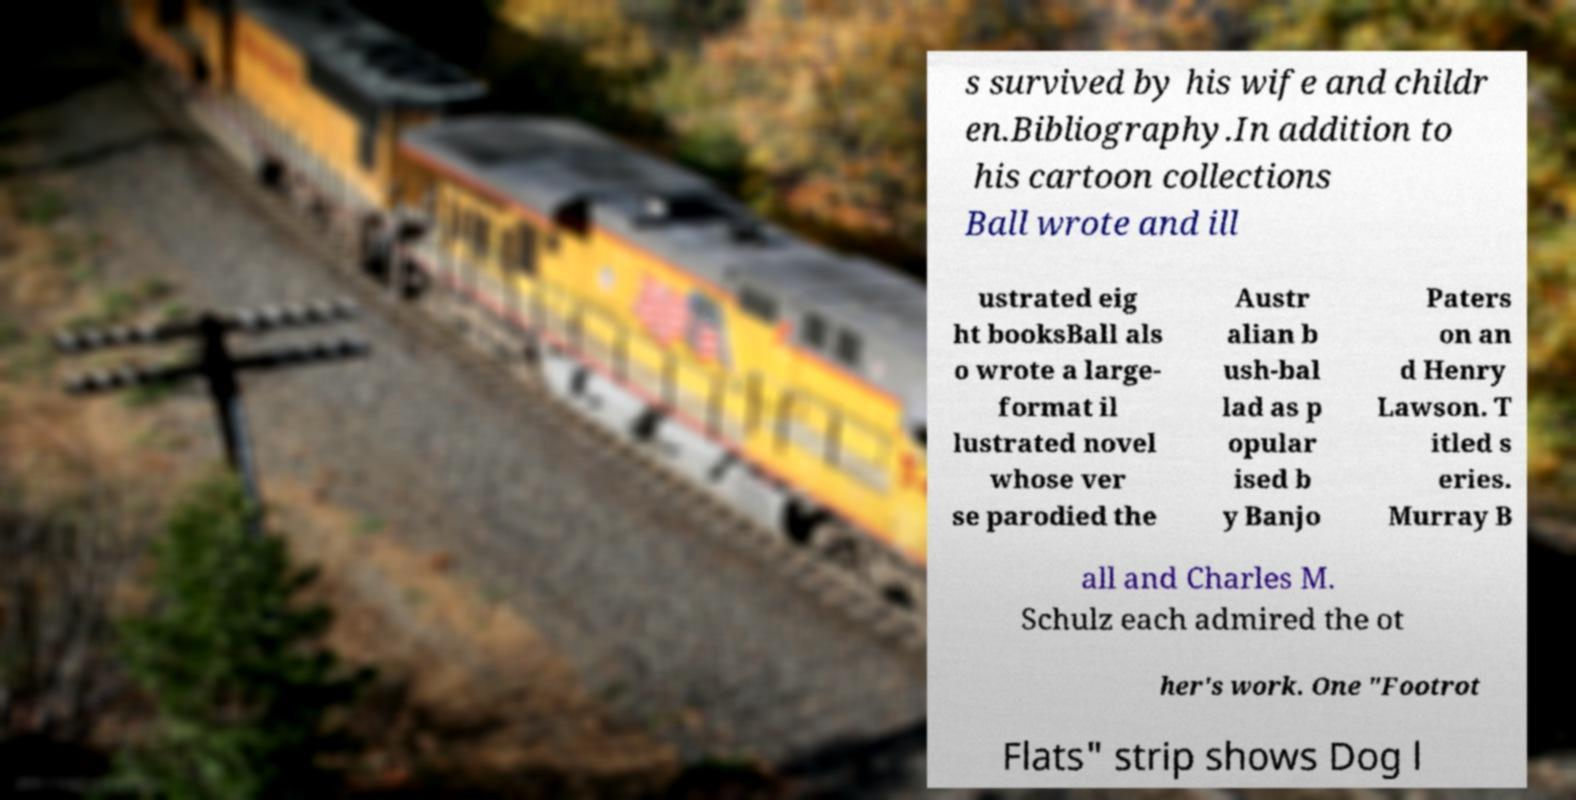Could you assist in decoding the text presented in this image and type it out clearly? s survived by his wife and childr en.Bibliography.In addition to his cartoon collections Ball wrote and ill ustrated eig ht booksBall als o wrote a large- format il lustrated novel whose ver se parodied the Austr alian b ush-bal lad as p opular ised b y Banjo Paters on an d Henry Lawson. T itled s eries. Murray B all and Charles M. Schulz each admired the ot her's work. One "Footrot Flats" strip shows Dog l 